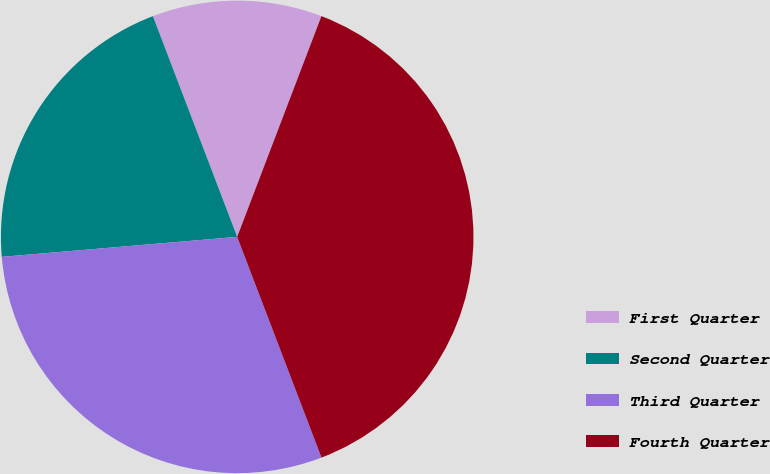Convert chart. <chart><loc_0><loc_0><loc_500><loc_500><pie_chart><fcel>First Quarter<fcel>Second Quarter<fcel>Third Quarter<fcel>Fourth Quarter<nl><fcel>11.61%<fcel>20.54%<fcel>29.46%<fcel>38.39%<nl></chart> 